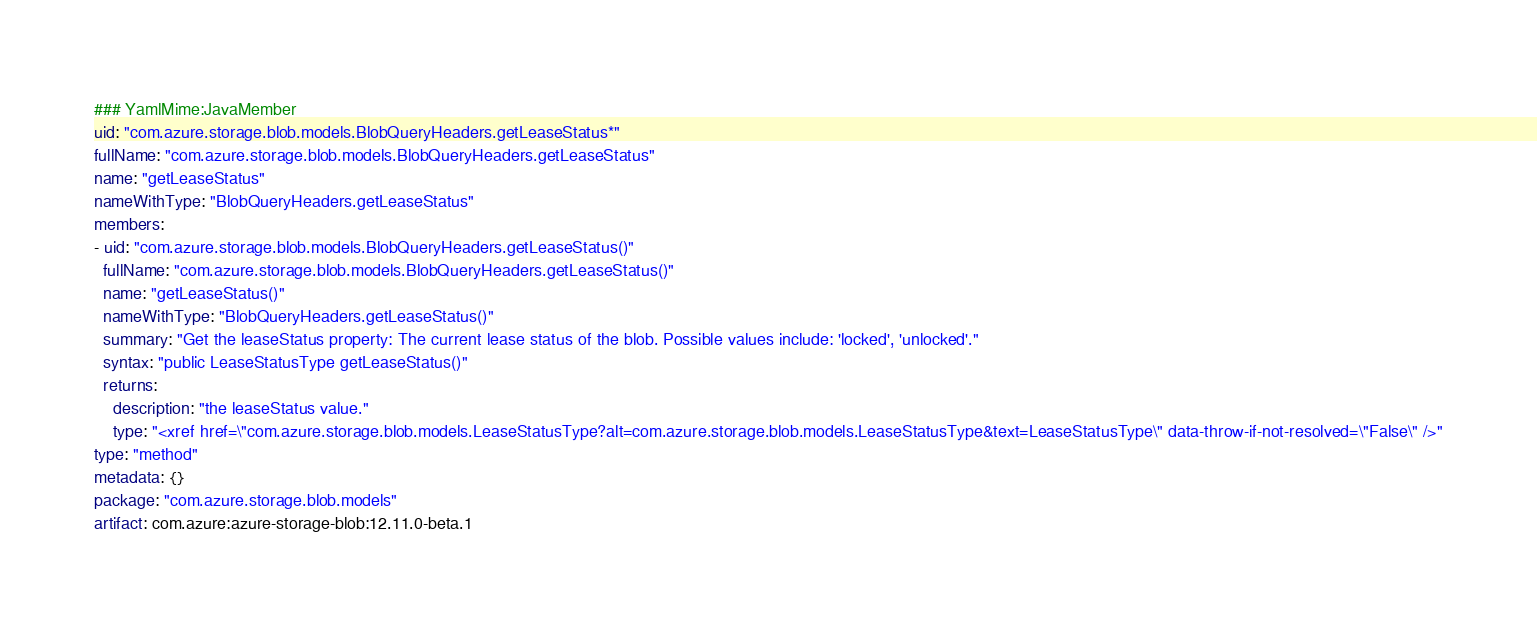<code> <loc_0><loc_0><loc_500><loc_500><_YAML_>### YamlMime:JavaMember
uid: "com.azure.storage.blob.models.BlobQueryHeaders.getLeaseStatus*"
fullName: "com.azure.storage.blob.models.BlobQueryHeaders.getLeaseStatus"
name: "getLeaseStatus"
nameWithType: "BlobQueryHeaders.getLeaseStatus"
members:
- uid: "com.azure.storage.blob.models.BlobQueryHeaders.getLeaseStatus()"
  fullName: "com.azure.storage.blob.models.BlobQueryHeaders.getLeaseStatus()"
  name: "getLeaseStatus()"
  nameWithType: "BlobQueryHeaders.getLeaseStatus()"
  summary: "Get the leaseStatus property: The current lease status of the blob. Possible values include: 'locked', 'unlocked'."
  syntax: "public LeaseStatusType getLeaseStatus()"
  returns:
    description: "the leaseStatus value."
    type: "<xref href=\"com.azure.storage.blob.models.LeaseStatusType?alt=com.azure.storage.blob.models.LeaseStatusType&text=LeaseStatusType\" data-throw-if-not-resolved=\"False\" />"
type: "method"
metadata: {}
package: "com.azure.storage.blob.models"
artifact: com.azure:azure-storage-blob:12.11.0-beta.1
</code> 